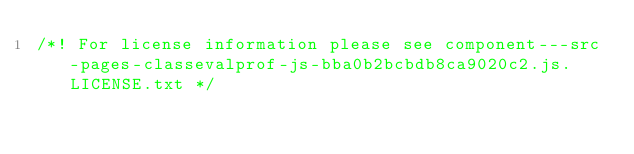<code> <loc_0><loc_0><loc_500><loc_500><_JavaScript_>/*! For license information please see component---src-pages-classevalprof-js-bba0b2bcbdb8ca9020c2.js.LICENSE.txt */</code> 